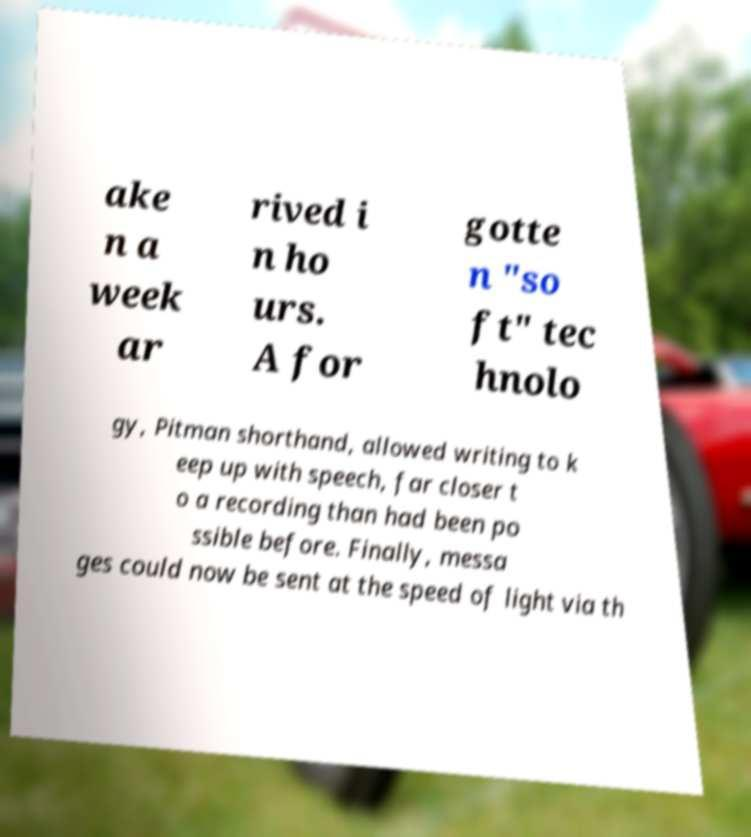Can you accurately transcribe the text from the provided image for me? ake n a week ar rived i n ho urs. A for gotte n "so ft" tec hnolo gy, Pitman shorthand, allowed writing to k eep up with speech, far closer t o a recording than had been po ssible before. Finally, messa ges could now be sent at the speed of light via th 